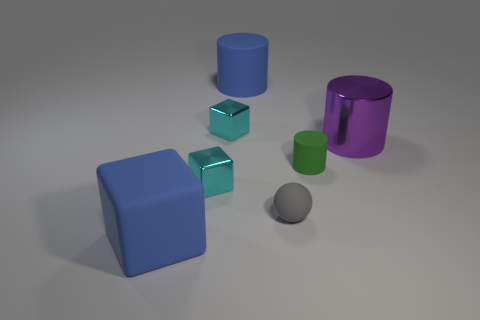There is a thing that is both in front of the big purple shiny thing and to the right of the sphere; what is its shape?
Your answer should be very brief. Cylinder. How many cyan objects are rubber balls or cylinders?
Keep it short and to the point. 0. Do the blue thing that is in front of the large purple metallic cylinder and the blue matte object behind the blue block have the same size?
Provide a short and direct response. Yes. What number of objects are either big blocks or large gray rubber balls?
Offer a terse response. 1. Are there any red metallic objects that have the same shape as the tiny green rubber thing?
Give a very brief answer. No. Is the number of red shiny objects less than the number of green objects?
Give a very brief answer. Yes. Is the shape of the small green object the same as the small gray object?
Provide a short and direct response. No. What number of objects are either matte cylinders or matte objects that are behind the gray thing?
Your answer should be very brief. 2. How many tiny green rubber balls are there?
Your response must be concise. 0. Are there any blue things that have the same size as the green cylinder?
Your response must be concise. No. 